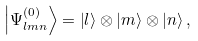<formula> <loc_0><loc_0><loc_500><loc_500>\left | \Psi _ { l m n } ^ { \left ( 0 \right ) } \right \rangle = \left | l \right \rangle \otimes \left | m \right \rangle \otimes \left | n \right \rangle ,</formula> 